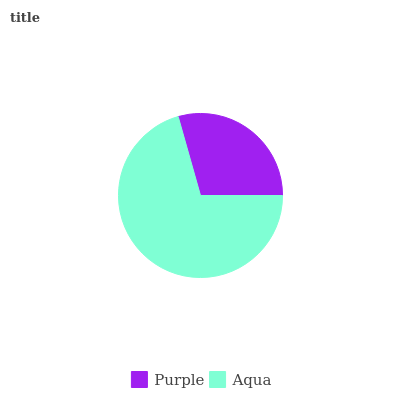Is Purple the minimum?
Answer yes or no. Yes. Is Aqua the maximum?
Answer yes or no. Yes. Is Aqua the minimum?
Answer yes or no. No. Is Aqua greater than Purple?
Answer yes or no. Yes. Is Purple less than Aqua?
Answer yes or no. Yes. Is Purple greater than Aqua?
Answer yes or no. No. Is Aqua less than Purple?
Answer yes or no. No. Is Aqua the high median?
Answer yes or no. Yes. Is Purple the low median?
Answer yes or no. Yes. Is Purple the high median?
Answer yes or no. No. Is Aqua the low median?
Answer yes or no. No. 